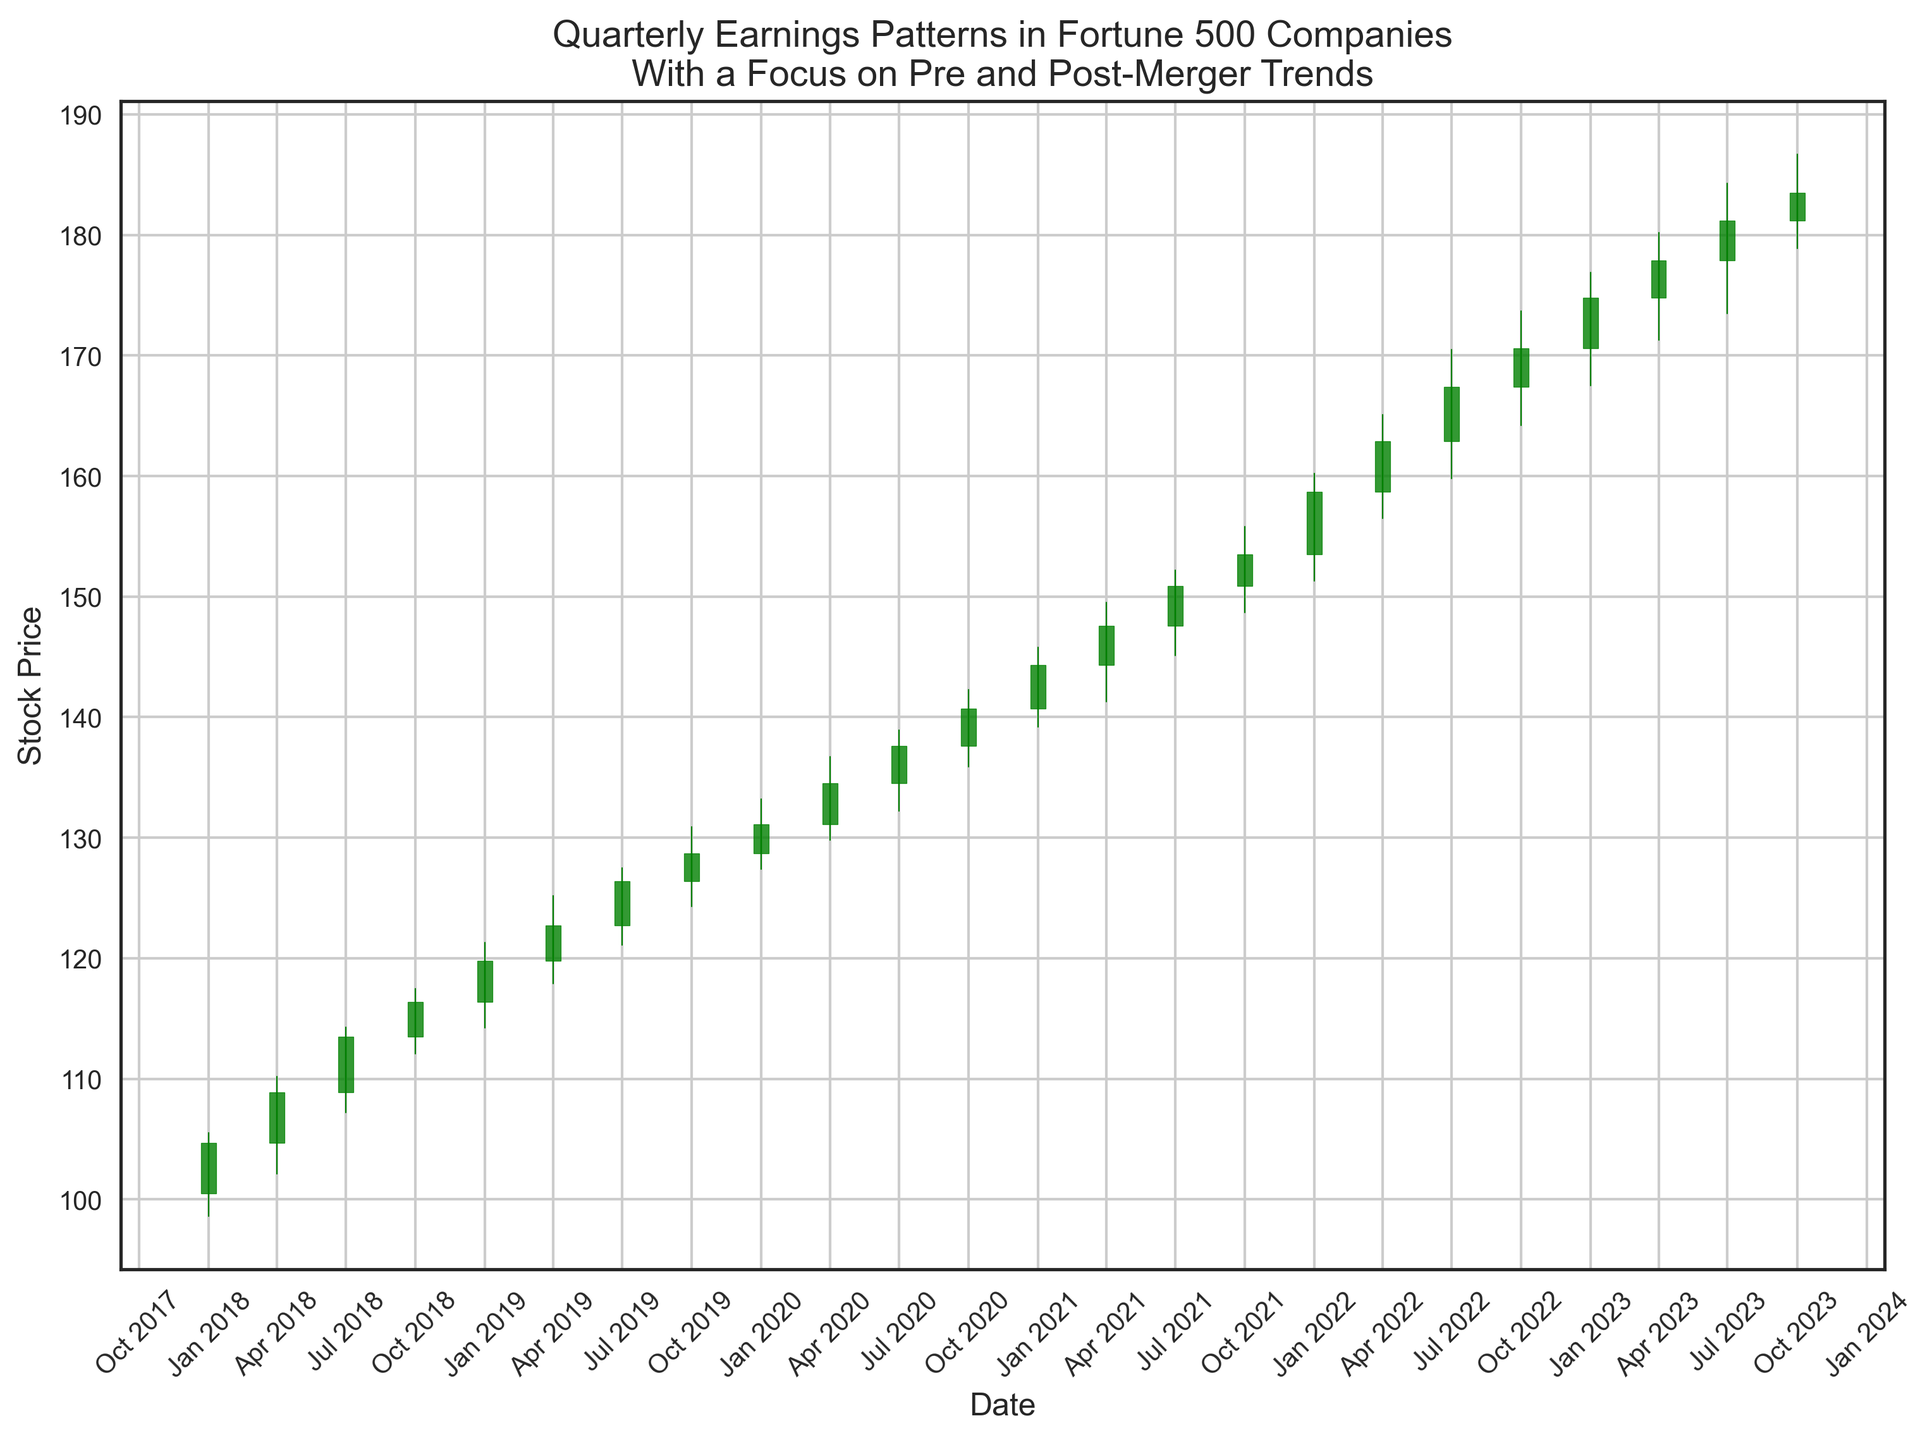What is the highest closing price observed in the post-merger period? Look at the closing prices represented at the end of each candlestick from 2020 onward. The highest closing price is found on the candlestick corresponding to October 1, 2023, which closes at 183.5.
Answer: 183.5 How does the volume compare between the pre-merger and post-merger periods? Observe the volume labels given for each quarter. The pre-merger period ends in 2019 with volumes increasing from 1,500,000 to 1,950,000. The post-merger period starting in 2020 has volumes increasing more significantly from 2,000,000 to 2,950,000.
Answer: Higher post-merger What was the percentage increase in closing prices from the start of 2021 to the start of 2023? The closing price at the start of 2021 was 144.3 and at the start of 2023 was 174.8. Calculate the percentage increase: ((174.8 - 144.3) / 144.3) * 100. This results in approximately 21.17%.
Answer: 21.17% Which quarter had the smallest range between the high and low prices in the post-merger period? Examine the differences between the high and low prices for each candlestick from 2020 onward. The smallest range occurs in January 2022 with high 160.2 and low 151.3, a difference of 8.9.
Answer: January 2022 What trend can be observed in the trading volume from 2018 to 2023? Observe the trading volume values at the bottom of the chart from 2018 to 2023. The volume shows a steady increase throughout the period, starting from 1,500,000 and reaching 2,950,000.
Answer: Increasing trend How frequently do the closing prices exceed the opening prices in the pre-merger period? Count the number of quarters in the pre-merger period (2018-2019) where the closing price is higher than the opening price. There are 6 such instances out of 8 quarters.
Answer: 6 out of 8 What is the average closing price for the year 2022? Sum the closing prices for each quarter in 2022 and divide by 4: (158.7 + 162.9 + 167.4 + 170.6) / 4 = approximately 164.9.
Answer: 164.9 Which year recorded the highest increase in quarterly closing prices in the pre-merger period? Compare the differences in quarterly closing prices for 2018 and 2019. The highest increase occurs in 2019, from 116.4 at the start of the year to 128.7 at the end.
Answer: 2019 How does the range of prices in the last quarter of 2023 compare to the average range of prices in 2023? Calculate the range for each quarter in 2023 and the average: ranges are (8.4, 8.9, 10.8, 7.8). Last quarter range is 7.8. Average is (8.4 + 8.9 + 10.8 + 7.8) / 4 = 8.975. The last quarter's range (7.8) is less than the average.
Answer: Less than average 